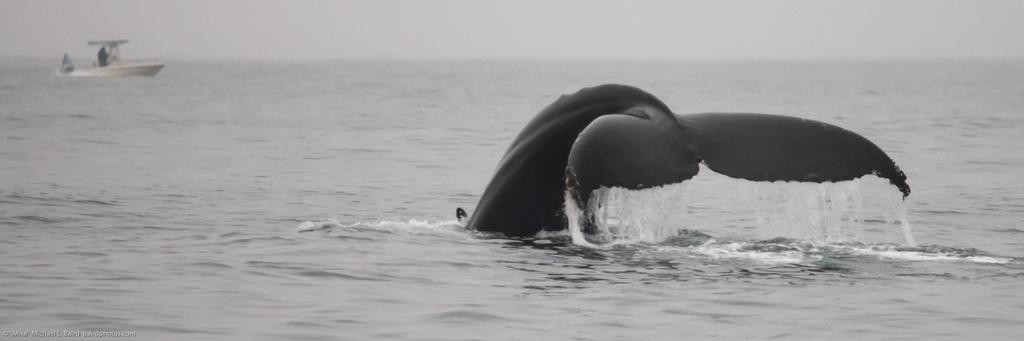What is the color scheme of the image? The image is black and white. What animal can be seen in the image? There is a whale in the image. What is the whale doing in the image? The whale is going into the water. What else can be seen in the background of the image? There is a boat in the background of the image. What type of cast is the whale wearing in the image? There is no cast visible on the whale in the image. What is the whale's reaction to the expansion of the water in the image? The image does not depict any expansion of the water, nor does it show the whale's reaction to it. 